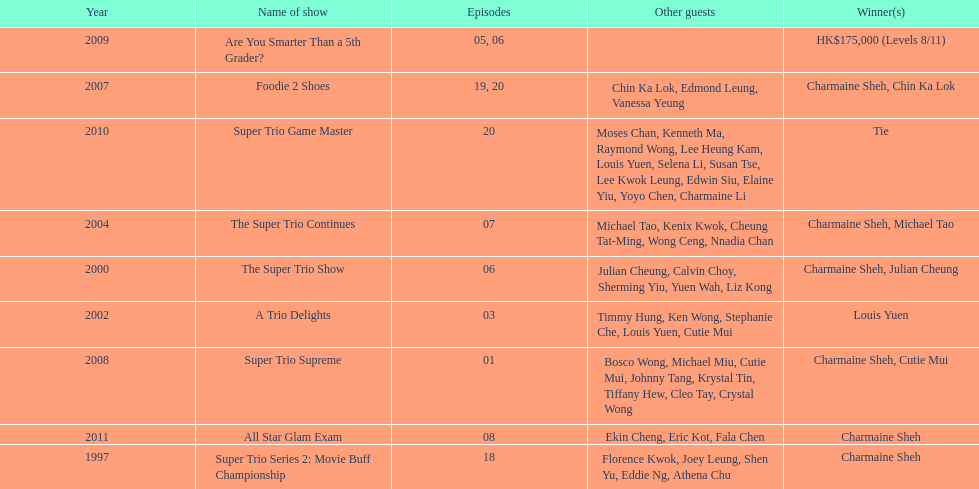What year was the only year were a tie occurred? 2010. 